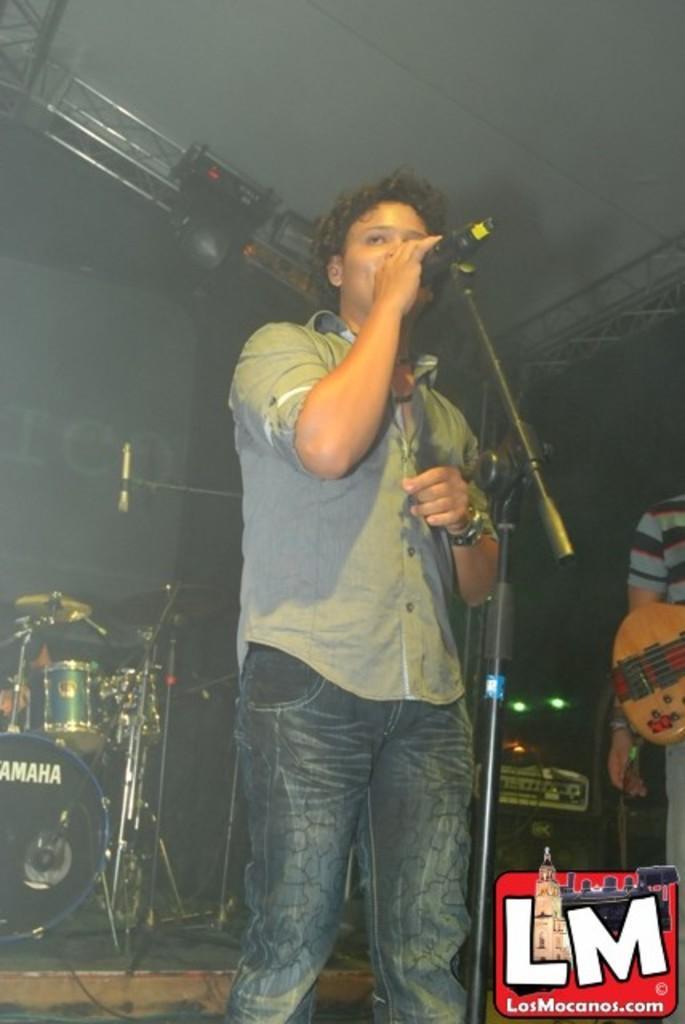Could you give a brief overview of what you see in this image? In this image we can see a man standing and singing, and in front here is the micro phone and stand, and at back here are the drums, and here is the person standing, and holding the guitar. 